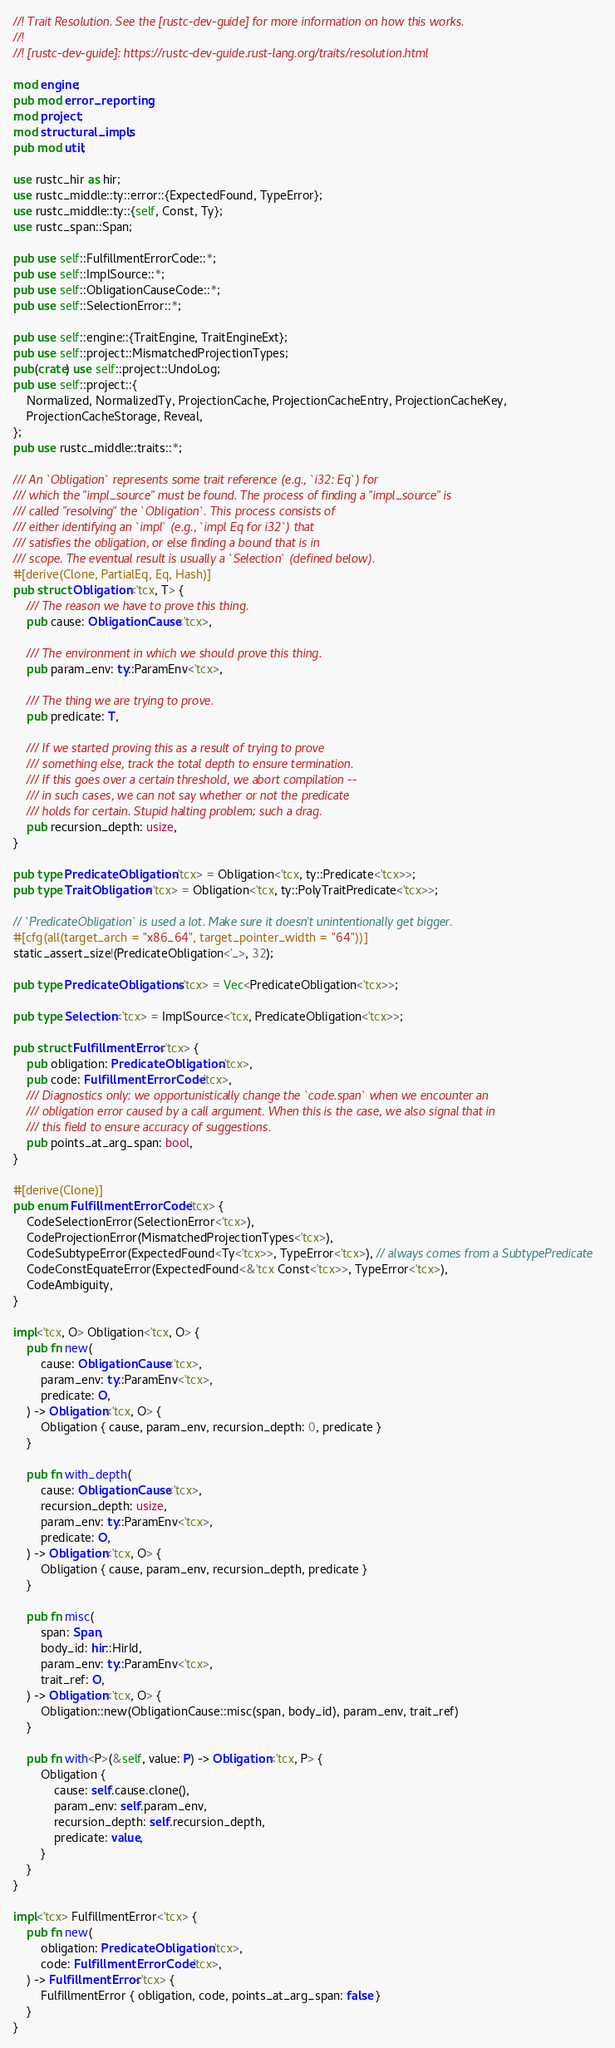<code> <loc_0><loc_0><loc_500><loc_500><_Rust_>//! Trait Resolution. See the [rustc-dev-guide] for more information on how this works.
//!
//! [rustc-dev-guide]: https://rustc-dev-guide.rust-lang.org/traits/resolution.html

mod engine;
pub mod error_reporting;
mod project;
mod structural_impls;
pub mod util;

use rustc_hir as hir;
use rustc_middle::ty::error::{ExpectedFound, TypeError};
use rustc_middle::ty::{self, Const, Ty};
use rustc_span::Span;

pub use self::FulfillmentErrorCode::*;
pub use self::ImplSource::*;
pub use self::ObligationCauseCode::*;
pub use self::SelectionError::*;

pub use self::engine::{TraitEngine, TraitEngineExt};
pub use self::project::MismatchedProjectionTypes;
pub(crate) use self::project::UndoLog;
pub use self::project::{
    Normalized, NormalizedTy, ProjectionCache, ProjectionCacheEntry, ProjectionCacheKey,
    ProjectionCacheStorage, Reveal,
};
pub use rustc_middle::traits::*;

/// An `Obligation` represents some trait reference (e.g., `i32: Eq`) for
/// which the "impl_source" must be found. The process of finding a "impl_source" is
/// called "resolving" the `Obligation`. This process consists of
/// either identifying an `impl` (e.g., `impl Eq for i32`) that
/// satisfies the obligation, or else finding a bound that is in
/// scope. The eventual result is usually a `Selection` (defined below).
#[derive(Clone, PartialEq, Eq, Hash)]
pub struct Obligation<'tcx, T> {
    /// The reason we have to prove this thing.
    pub cause: ObligationCause<'tcx>,

    /// The environment in which we should prove this thing.
    pub param_env: ty::ParamEnv<'tcx>,

    /// The thing we are trying to prove.
    pub predicate: T,

    /// If we started proving this as a result of trying to prove
    /// something else, track the total depth to ensure termination.
    /// If this goes over a certain threshold, we abort compilation --
    /// in such cases, we can not say whether or not the predicate
    /// holds for certain. Stupid halting problem; such a drag.
    pub recursion_depth: usize,
}

pub type PredicateObligation<'tcx> = Obligation<'tcx, ty::Predicate<'tcx>>;
pub type TraitObligation<'tcx> = Obligation<'tcx, ty::PolyTraitPredicate<'tcx>>;

// `PredicateObligation` is used a lot. Make sure it doesn't unintentionally get bigger.
#[cfg(all(target_arch = "x86_64", target_pointer_width = "64"))]
static_assert_size!(PredicateObligation<'_>, 32);

pub type PredicateObligations<'tcx> = Vec<PredicateObligation<'tcx>>;

pub type Selection<'tcx> = ImplSource<'tcx, PredicateObligation<'tcx>>;

pub struct FulfillmentError<'tcx> {
    pub obligation: PredicateObligation<'tcx>,
    pub code: FulfillmentErrorCode<'tcx>,
    /// Diagnostics only: we opportunistically change the `code.span` when we encounter an
    /// obligation error caused by a call argument. When this is the case, we also signal that in
    /// this field to ensure accuracy of suggestions.
    pub points_at_arg_span: bool,
}

#[derive(Clone)]
pub enum FulfillmentErrorCode<'tcx> {
    CodeSelectionError(SelectionError<'tcx>),
    CodeProjectionError(MismatchedProjectionTypes<'tcx>),
    CodeSubtypeError(ExpectedFound<Ty<'tcx>>, TypeError<'tcx>), // always comes from a SubtypePredicate
    CodeConstEquateError(ExpectedFound<&'tcx Const<'tcx>>, TypeError<'tcx>),
    CodeAmbiguity,
}

impl<'tcx, O> Obligation<'tcx, O> {
    pub fn new(
        cause: ObligationCause<'tcx>,
        param_env: ty::ParamEnv<'tcx>,
        predicate: O,
    ) -> Obligation<'tcx, O> {
        Obligation { cause, param_env, recursion_depth: 0, predicate }
    }

    pub fn with_depth(
        cause: ObligationCause<'tcx>,
        recursion_depth: usize,
        param_env: ty::ParamEnv<'tcx>,
        predicate: O,
    ) -> Obligation<'tcx, O> {
        Obligation { cause, param_env, recursion_depth, predicate }
    }

    pub fn misc(
        span: Span,
        body_id: hir::HirId,
        param_env: ty::ParamEnv<'tcx>,
        trait_ref: O,
    ) -> Obligation<'tcx, O> {
        Obligation::new(ObligationCause::misc(span, body_id), param_env, trait_ref)
    }

    pub fn with<P>(&self, value: P) -> Obligation<'tcx, P> {
        Obligation {
            cause: self.cause.clone(),
            param_env: self.param_env,
            recursion_depth: self.recursion_depth,
            predicate: value,
        }
    }
}

impl<'tcx> FulfillmentError<'tcx> {
    pub fn new(
        obligation: PredicateObligation<'tcx>,
        code: FulfillmentErrorCode<'tcx>,
    ) -> FulfillmentError<'tcx> {
        FulfillmentError { obligation, code, points_at_arg_span: false }
    }
}
</code> 